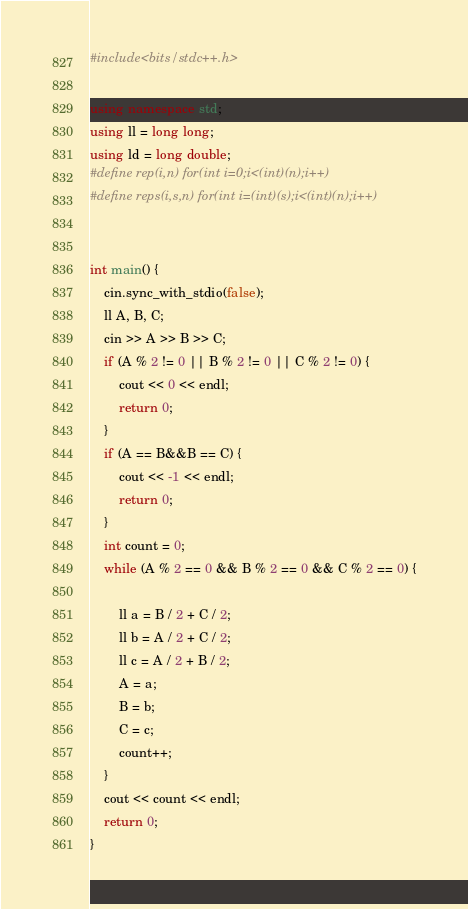<code> <loc_0><loc_0><loc_500><loc_500><_C++_>#include<bits/stdc++.h>

using namespace std;
using ll = long long;
using ld = long double;
#define rep(i,n) for(int i=0;i<(int)(n);i++)
#define reps(i,s,n) for(int i=(int)(s);i<(int)(n);i++)


int main() {
	cin.sync_with_stdio(false);
	ll A, B, C;
	cin >> A >> B >> C;
	if (A % 2 != 0 || B % 2 != 0 || C % 2 != 0) {
		cout << 0 << endl;
		return 0;
	}
	if (A == B&&B == C) {
		cout << -1 << endl;
		return 0;
	}
	int count = 0;
	while (A % 2 == 0 && B % 2 == 0 && C % 2 == 0) {
		
		ll a = B / 2 + C / 2;
		ll b = A / 2 + C / 2;
		ll c = A / 2 + B / 2;
		A = a;
		B = b;
		C = c;
		count++;
	}
	cout << count << endl;
	return 0;
}</code> 